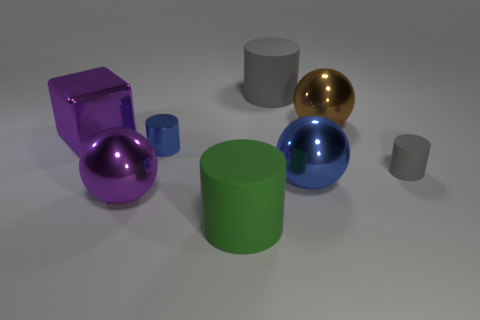Subtract all blue shiny cylinders. How many cylinders are left? 3 Subtract all balls. How many objects are left? 5 Subtract 3 cylinders. How many cylinders are left? 1 Add 1 brown matte cylinders. How many brown matte cylinders exist? 1 Add 1 small purple things. How many objects exist? 9 Subtract all purple balls. How many balls are left? 2 Subtract 0 cyan spheres. How many objects are left? 8 Subtract all blue cylinders. Subtract all red spheres. How many cylinders are left? 3 Subtract all gray cubes. How many green cylinders are left? 1 Subtract all small gray matte objects. Subtract all green matte objects. How many objects are left? 6 